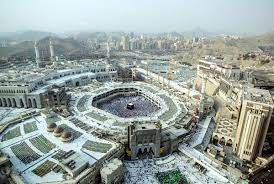What time of year do you think this photo was taken and why? This photo likely captures a moment outside the annual Hajj season, perhaps during a quieter period. The absence of dense crowds, which are typical during Hajj, and the array of weather conditions visible suggest a possibly cooler season. Recognizing the calm in the area gives us a rare view of the structural details of the mosque and its surroundings. 